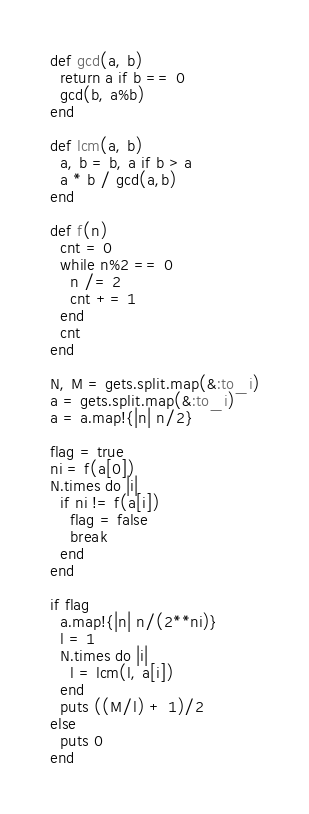<code> <loc_0><loc_0><loc_500><loc_500><_Ruby_>def gcd(a, b)
  return a if b == 0
  gcd(b, a%b)
end

def lcm(a, b)
  a, b = b, a if b > a
  a * b / gcd(a,b)
end

def f(n)
  cnt = 0
  while n%2 == 0
    n /= 2
    cnt += 1
  end
  cnt
end

N, M = gets.split.map(&:to_i)
a = gets.split.map(&:to_i)
a = a.map!{|n| n/2}

flag = true
ni = f(a[0])
N.times do |i|
  if ni != f(a[i])
    flag = false
    break
  end
end

if flag
  a.map!{|n| n/(2**ni)}
  l = 1
  N.times do |i|
    l = lcm(l, a[i])
  end
  puts ((M/l) + 1)/2
else
  puts 0
end</code> 